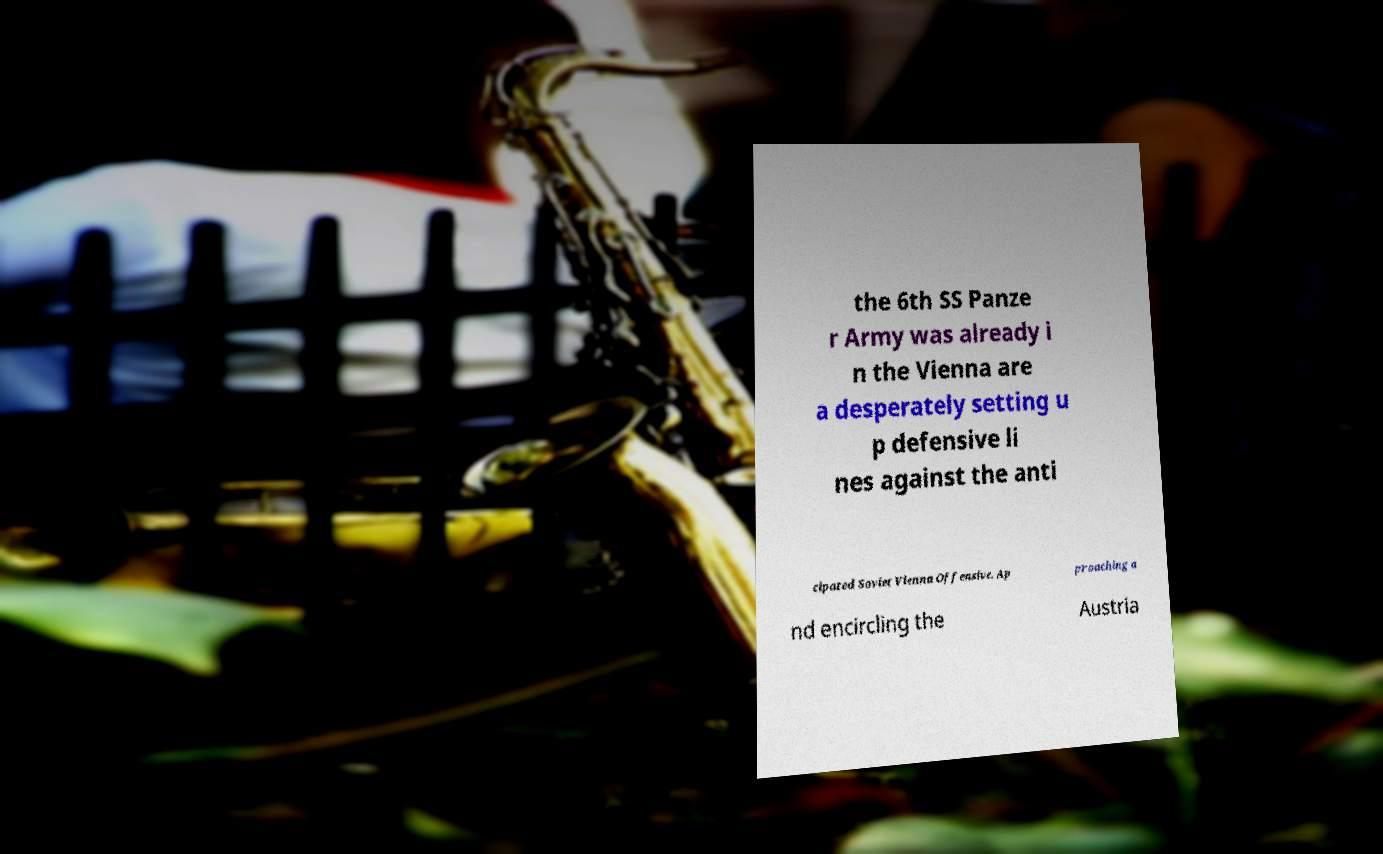Can you read and provide the text displayed in the image?This photo seems to have some interesting text. Can you extract and type it out for me? the 6th SS Panze r Army was already i n the Vienna are a desperately setting u p defensive li nes against the anti cipated Soviet Vienna Offensive. Ap proaching a nd encircling the Austria 